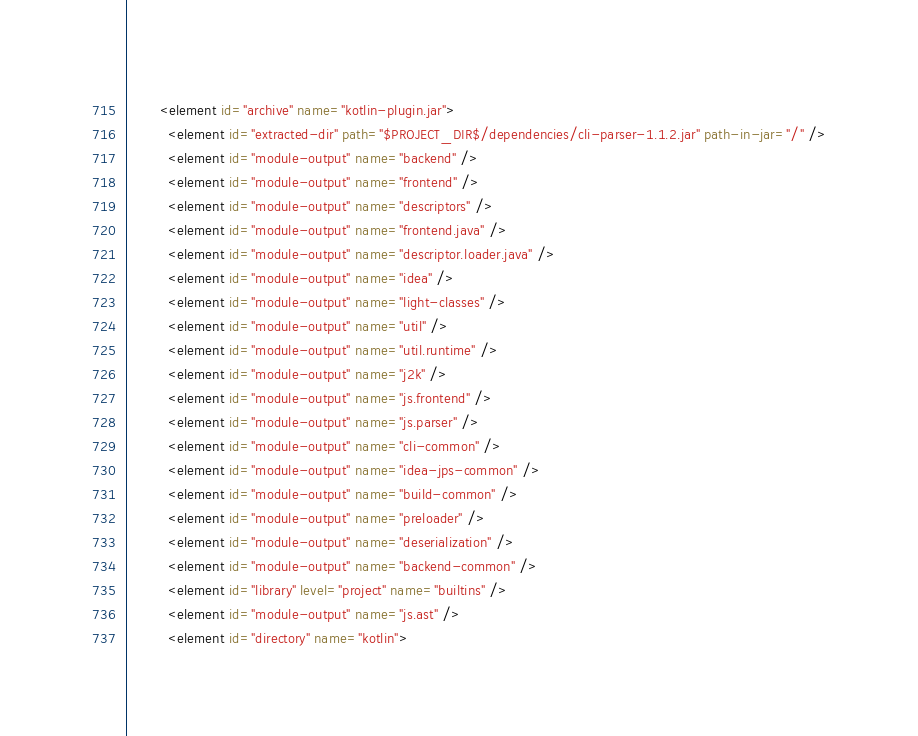<code> <loc_0><loc_0><loc_500><loc_500><_XML_>        <element id="archive" name="kotlin-plugin.jar">
          <element id="extracted-dir" path="$PROJECT_DIR$/dependencies/cli-parser-1.1.2.jar" path-in-jar="/" />
          <element id="module-output" name="backend" />
          <element id="module-output" name="frontend" />
          <element id="module-output" name="descriptors" />
          <element id="module-output" name="frontend.java" />
          <element id="module-output" name="descriptor.loader.java" />
          <element id="module-output" name="idea" />
          <element id="module-output" name="light-classes" />
          <element id="module-output" name="util" />
          <element id="module-output" name="util.runtime" />
          <element id="module-output" name="j2k" />
          <element id="module-output" name="js.frontend" />
          <element id="module-output" name="js.parser" />
          <element id="module-output" name="cli-common" />
          <element id="module-output" name="idea-jps-common" />
          <element id="module-output" name="build-common" />
          <element id="module-output" name="preloader" />
          <element id="module-output" name="deserialization" />
          <element id="module-output" name="backend-common" />
          <element id="library" level="project" name="builtins" />
          <element id="module-output" name="js.ast" />
          <element id="directory" name="kotlin"></code> 